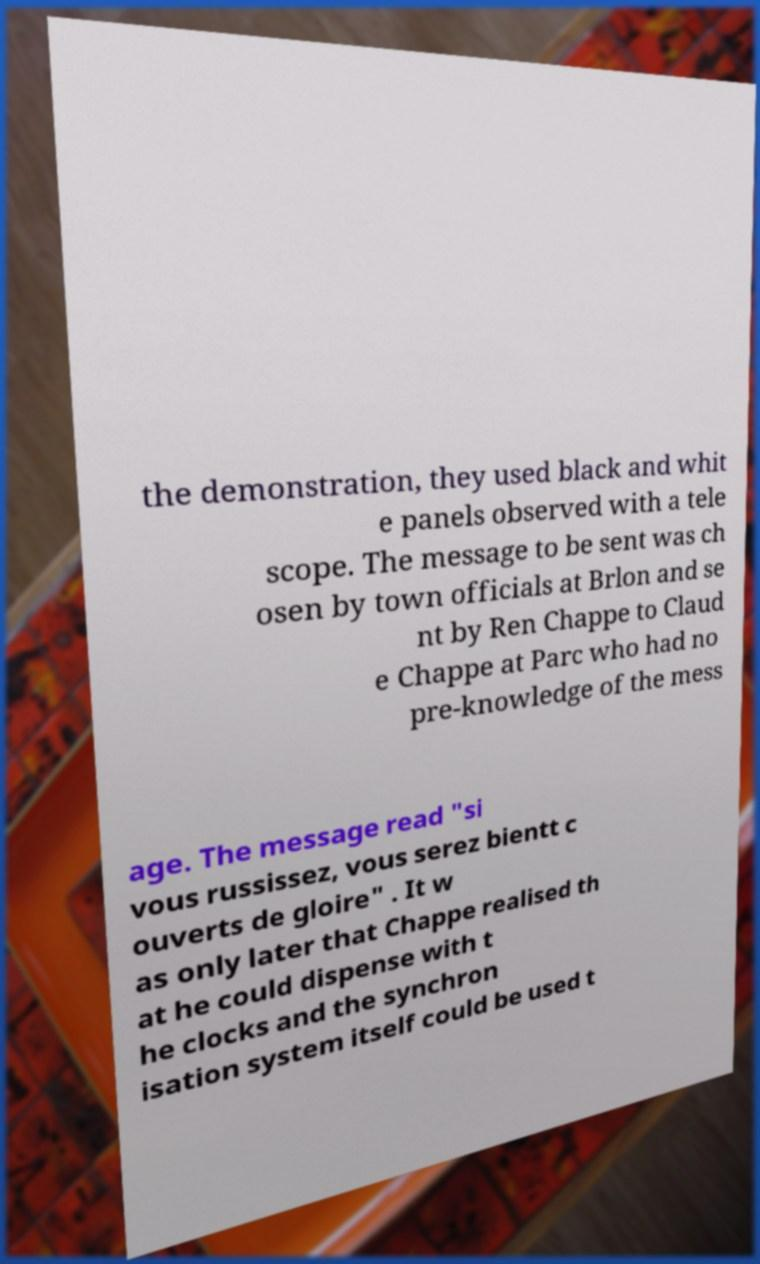There's text embedded in this image that I need extracted. Can you transcribe it verbatim? the demonstration, they used black and whit e panels observed with a tele scope. The message to be sent was ch osen by town officials at Brlon and se nt by Ren Chappe to Claud e Chappe at Parc who had no pre-knowledge of the mess age. The message read "si vous russissez, vous serez bientt c ouverts de gloire" . It w as only later that Chappe realised th at he could dispense with t he clocks and the synchron isation system itself could be used t 